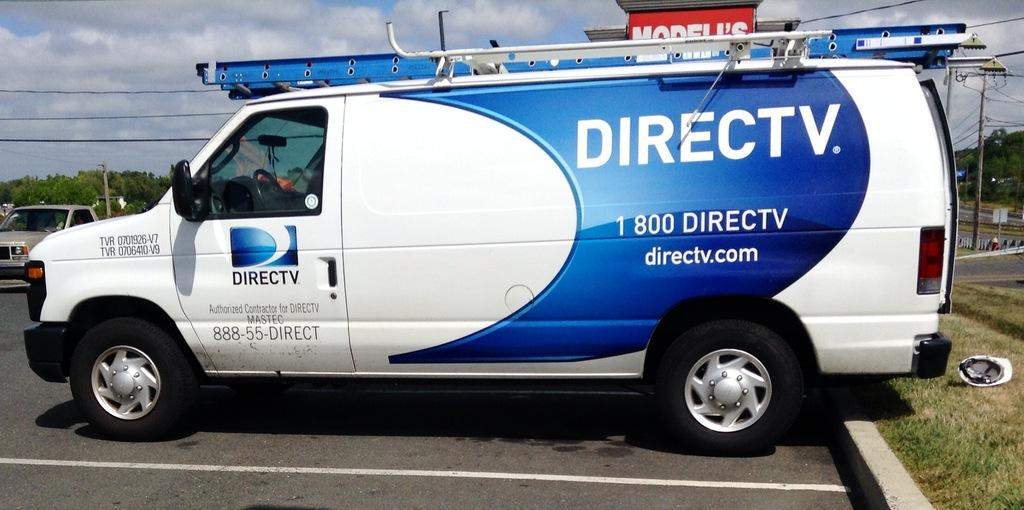Provide a one-sentence caption for the provided image. A Direct TV van is backed into a parking spot. 